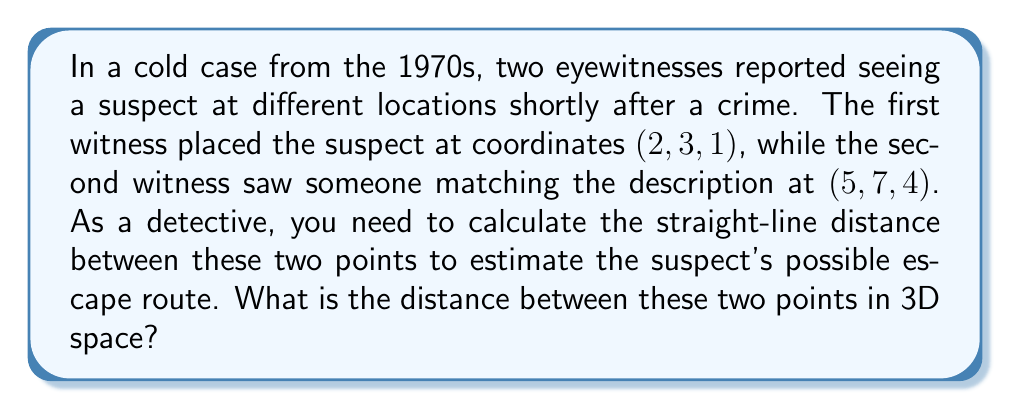Teach me how to tackle this problem. To solve this problem, we'll use the distance formula for two points in three-dimensional space. The formula is derived from the Pythagorean theorem extended to three dimensions.

Given:
- Point 1: $(x_1, y_1, z_1) = (2, 3, 1)$
- Point 2: $(x_2, y_2, z_2) = (5, 7, 4)$

The distance formula in 3D space is:

$$d = \sqrt{(x_2 - x_1)^2 + (y_2 - y_1)^2 + (z_2 - z_1)^2}$$

Let's substitute the values:

$$\begin{align}
d &= \sqrt{(5 - 2)^2 + (7 - 3)^2 + (4 - 1)^2} \\
&= \sqrt{3^2 + 4^2 + 3^2} \\
&= \sqrt{9 + 16 + 9} \\
&= \sqrt{34}
\end{align}$$

The distance between the two points is $\sqrt{34}$ units.

To get a decimal approximation:
$$\sqrt{34} \approx 5.83$$

[asy]
import three;
size(200);
currentprojection=perspective(6,3,2);
draw(O--6X,gray+dashed);
draw(O--8Y,gray+dashed);
draw(O--5Z,gray+dashed);
dot((2,3,1),red);
dot((5,7,4),red);
draw((2,3,1)--(5,7,4),blue);
label("(2,3,1)",(2,3,1),SW);
label("(5,7,4)",(5,7,4),NE);
[/asy]
Answer: The distance between the two points is $\sqrt{34}$ units, or approximately 5.83 units. 